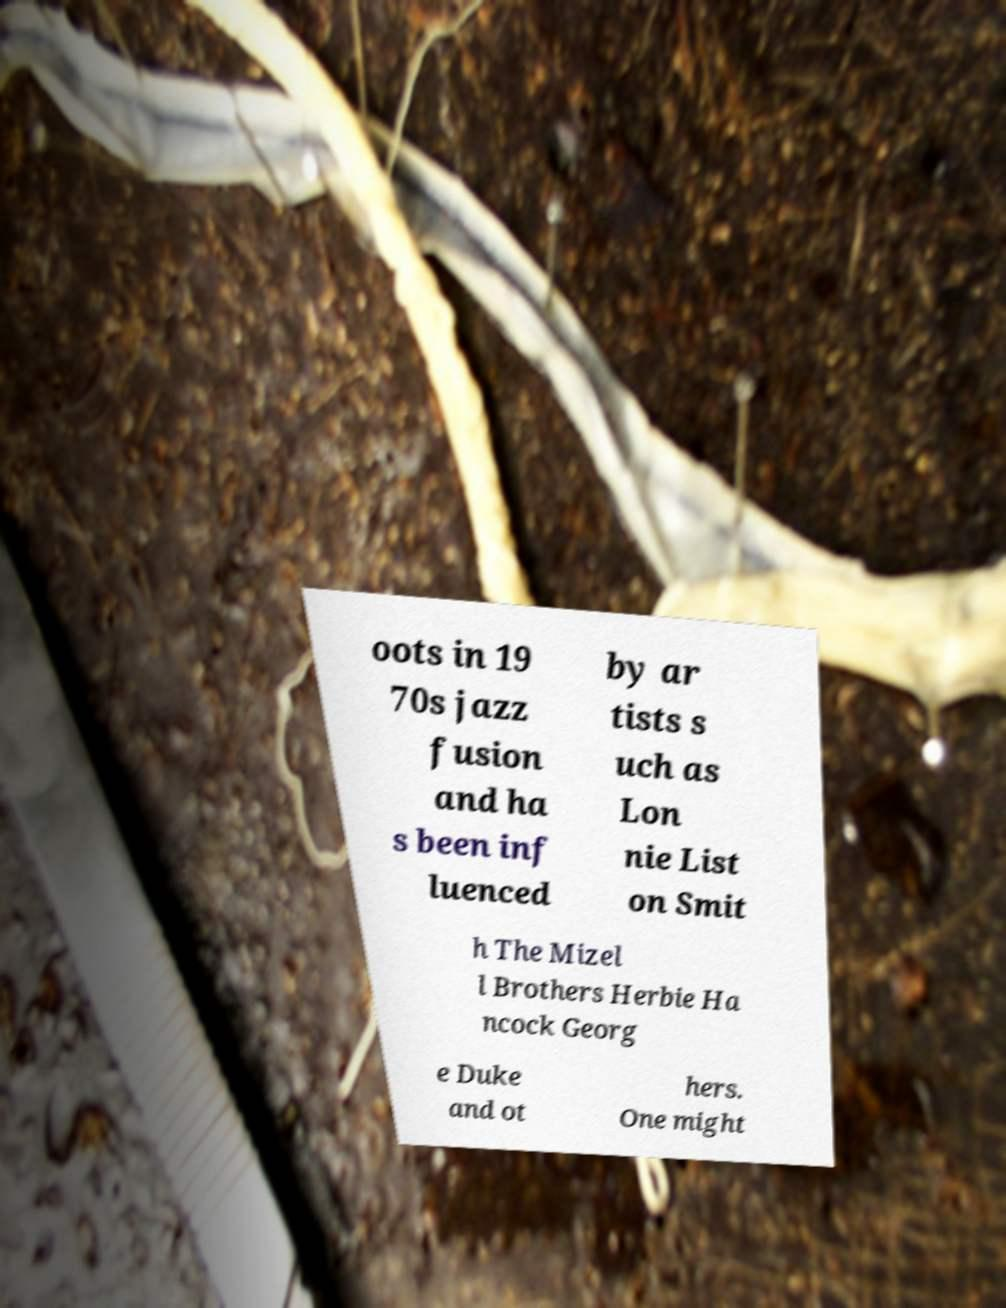Please identify and transcribe the text found in this image. oots in 19 70s jazz fusion and ha s been inf luenced by ar tists s uch as Lon nie List on Smit h The Mizel l Brothers Herbie Ha ncock Georg e Duke and ot hers. One might 